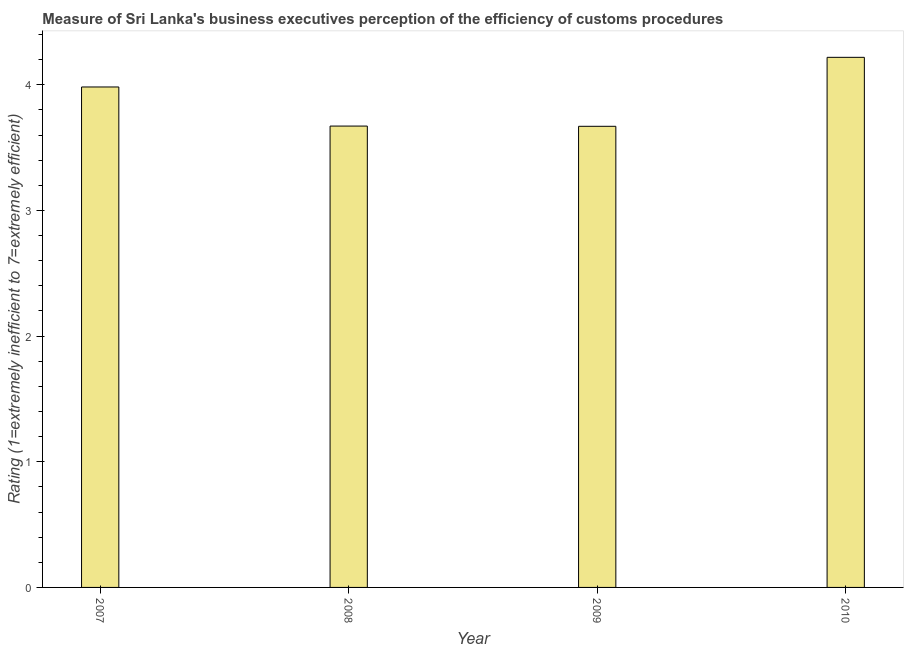Does the graph contain any zero values?
Your answer should be very brief. No. What is the title of the graph?
Your response must be concise. Measure of Sri Lanka's business executives perception of the efficiency of customs procedures. What is the label or title of the X-axis?
Offer a terse response. Year. What is the label or title of the Y-axis?
Ensure brevity in your answer.  Rating (1=extremely inefficient to 7=extremely efficient). What is the rating measuring burden of customs procedure in 2008?
Your answer should be very brief. 3.67. Across all years, what is the maximum rating measuring burden of customs procedure?
Provide a short and direct response. 4.22. Across all years, what is the minimum rating measuring burden of customs procedure?
Your answer should be compact. 3.67. In which year was the rating measuring burden of customs procedure minimum?
Ensure brevity in your answer.  2009. What is the sum of the rating measuring burden of customs procedure?
Your answer should be very brief. 15.54. What is the difference between the rating measuring burden of customs procedure in 2009 and 2010?
Give a very brief answer. -0.55. What is the average rating measuring burden of customs procedure per year?
Provide a succinct answer. 3.89. What is the median rating measuring burden of customs procedure?
Provide a short and direct response. 3.83. What is the ratio of the rating measuring burden of customs procedure in 2008 to that in 2009?
Your response must be concise. 1. Is the rating measuring burden of customs procedure in 2008 less than that in 2010?
Give a very brief answer. Yes. Is the difference between the rating measuring burden of customs procedure in 2008 and 2010 greater than the difference between any two years?
Your answer should be very brief. No. What is the difference between the highest and the second highest rating measuring burden of customs procedure?
Offer a very short reply. 0.24. What is the difference between the highest and the lowest rating measuring burden of customs procedure?
Offer a very short reply. 0.55. In how many years, is the rating measuring burden of customs procedure greater than the average rating measuring burden of customs procedure taken over all years?
Keep it short and to the point. 2. How many bars are there?
Ensure brevity in your answer.  4. How many years are there in the graph?
Offer a very short reply. 4. What is the difference between two consecutive major ticks on the Y-axis?
Provide a succinct answer. 1. Are the values on the major ticks of Y-axis written in scientific E-notation?
Offer a very short reply. No. What is the Rating (1=extremely inefficient to 7=extremely efficient) in 2007?
Give a very brief answer. 3.98. What is the Rating (1=extremely inefficient to 7=extremely efficient) in 2008?
Provide a succinct answer. 3.67. What is the Rating (1=extremely inefficient to 7=extremely efficient) in 2009?
Offer a very short reply. 3.67. What is the Rating (1=extremely inefficient to 7=extremely efficient) in 2010?
Make the answer very short. 4.22. What is the difference between the Rating (1=extremely inefficient to 7=extremely efficient) in 2007 and 2008?
Give a very brief answer. 0.31. What is the difference between the Rating (1=extremely inefficient to 7=extremely efficient) in 2007 and 2009?
Provide a short and direct response. 0.31. What is the difference between the Rating (1=extremely inefficient to 7=extremely efficient) in 2007 and 2010?
Provide a short and direct response. -0.24. What is the difference between the Rating (1=extremely inefficient to 7=extremely efficient) in 2008 and 2009?
Make the answer very short. 0. What is the difference between the Rating (1=extremely inefficient to 7=extremely efficient) in 2008 and 2010?
Ensure brevity in your answer.  -0.55. What is the difference between the Rating (1=extremely inefficient to 7=extremely efficient) in 2009 and 2010?
Your response must be concise. -0.55. What is the ratio of the Rating (1=extremely inefficient to 7=extremely efficient) in 2007 to that in 2008?
Offer a terse response. 1.08. What is the ratio of the Rating (1=extremely inefficient to 7=extremely efficient) in 2007 to that in 2009?
Keep it short and to the point. 1.08. What is the ratio of the Rating (1=extremely inefficient to 7=extremely efficient) in 2007 to that in 2010?
Give a very brief answer. 0.94. What is the ratio of the Rating (1=extremely inefficient to 7=extremely efficient) in 2008 to that in 2010?
Your answer should be very brief. 0.87. What is the ratio of the Rating (1=extremely inefficient to 7=extremely efficient) in 2009 to that in 2010?
Make the answer very short. 0.87. 